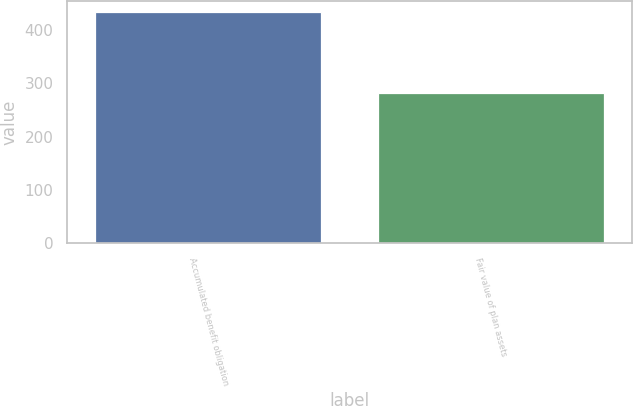Convert chart. <chart><loc_0><loc_0><loc_500><loc_500><bar_chart><fcel>Accumulated benefit obligation<fcel>Fair value of plan assets<nl><fcel>434<fcel>282<nl></chart> 